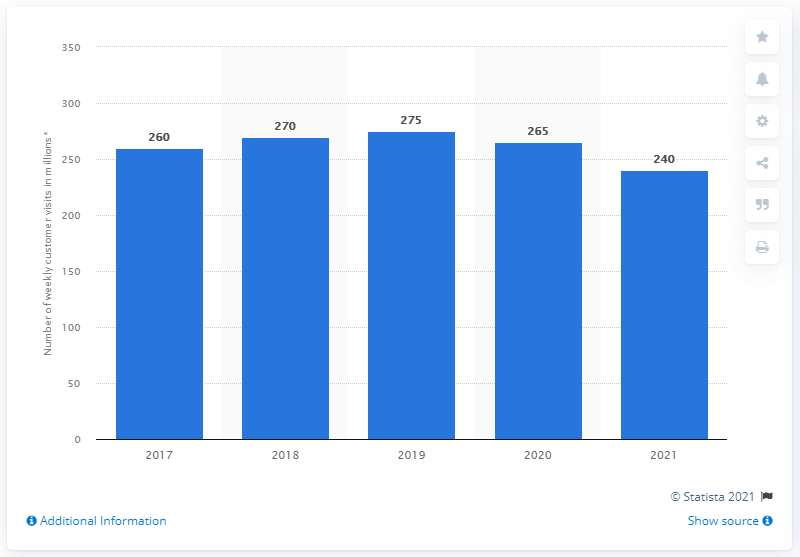Indicate a few pertinent items in this graphic. In 2021, Walmart reported that a total of 265 customers visited its physical stores. In 2021, Walmart had a total of 240 customers visit its stores. 